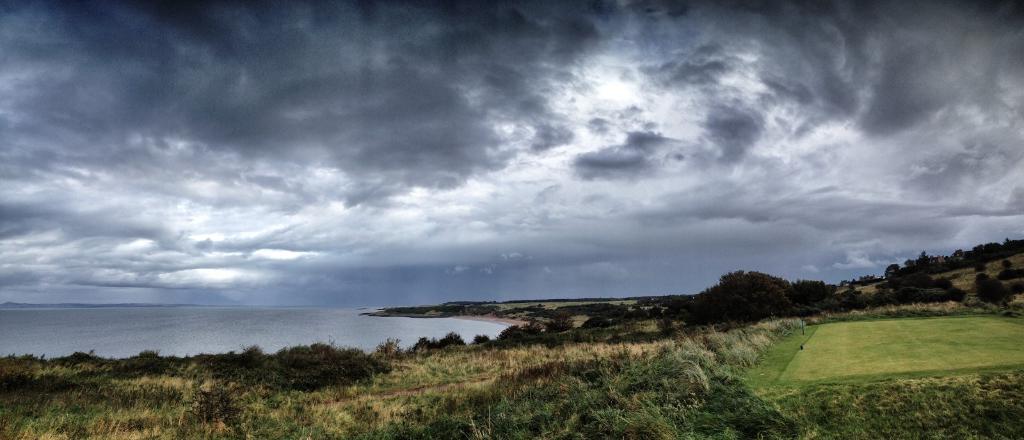Please provide a concise description of this image. In the center of the image we can see trees, grass, ground are present. On the left side of the image water is there. At the top of the image clouds are present in the sky. 